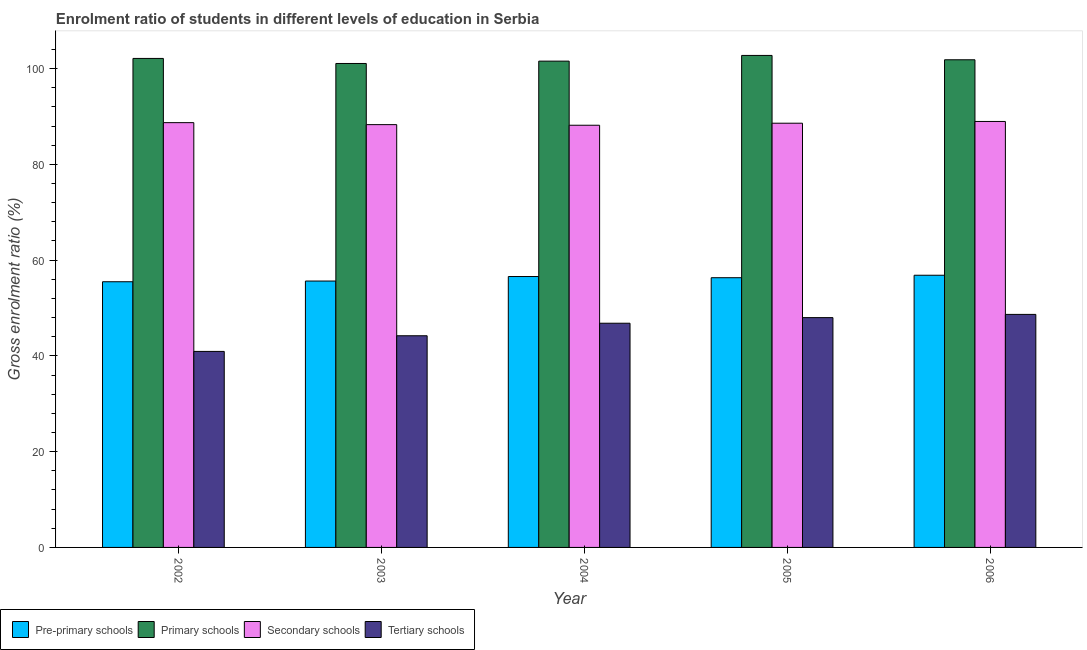Are the number of bars per tick equal to the number of legend labels?
Your answer should be very brief. Yes. How many bars are there on the 4th tick from the left?
Provide a succinct answer. 4. How many bars are there on the 5th tick from the right?
Your response must be concise. 4. What is the label of the 5th group of bars from the left?
Provide a short and direct response. 2006. In how many cases, is the number of bars for a given year not equal to the number of legend labels?
Provide a succinct answer. 0. What is the gross enrolment ratio in primary schools in 2006?
Ensure brevity in your answer.  101.84. Across all years, what is the maximum gross enrolment ratio in secondary schools?
Offer a terse response. 88.96. Across all years, what is the minimum gross enrolment ratio in tertiary schools?
Keep it short and to the point. 40.93. What is the total gross enrolment ratio in secondary schools in the graph?
Offer a very short reply. 442.72. What is the difference between the gross enrolment ratio in primary schools in 2003 and that in 2004?
Ensure brevity in your answer.  -0.49. What is the difference between the gross enrolment ratio in tertiary schools in 2004 and the gross enrolment ratio in secondary schools in 2002?
Offer a terse response. 5.89. What is the average gross enrolment ratio in tertiary schools per year?
Keep it short and to the point. 45.72. In the year 2006, what is the difference between the gross enrolment ratio in pre-primary schools and gross enrolment ratio in secondary schools?
Offer a very short reply. 0. In how many years, is the gross enrolment ratio in primary schools greater than 84 %?
Provide a succinct answer. 5. What is the ratio of the gross enrolment ratio in secondary schools in 2004 to that in 2005?
Give a very brief answer. 1. Is the gross enrolment ratio in secondary schools in 2004 less than that in 2005?
Your answer should be very brief. Yes. Is the difference between the gross enrolment ratio in tertiary schools in 2003 and 2004 greater than the difference between the gross enrolment ratio in secondary schools in 2003 and 2004?
Give a very brief answer. No. What is the difference between the highest and the second highest gross enrolment ratio in secondary schools?
Your response must be concise. 0.25. What is the difference between the highest and the lowest gross enrolment ratio in tertiary schools?
Your answer should be very brief. 7.73. In how many years, is the gross enrolment ratio in secondary schools greater than the average gross enrolment ratio in secondary schools taken over all years?
Make the answer very short. 3. What does the 1st bar from the left in 2005 represents?
Ensure brevity in your answer.  Pre-primary schools. What does the 1st bar from the right in 2002 represents?
Offer a very short reply. Tertiary schools. How many bars are there?
Your response must be concise. 20. Are all the bars in the graph horizontal?
Offer a terse response. No. How many years are there in the graph?
Make the answer very short. 5. What is the difference between two consecutive major ticks on the Y-axis?
Your answer should be compact. 20. Are the values on the major ticks of Y-axis written in scientific E-notation?
Ensure brevity in your answer.  No. Does the graph contain any zero values?
Provide a succinct answer. No. Where does the legend appear in the graph?
Your answer should be very brief. Bottom left. What is the title of the graph?
Provide a short and direct response. Enrolment ratio of students in different levels of education in Serbia. What is the label or title of the X-axis?
Ensure brevity in your answer.  Year. What is the Gross enrolment ratio (%) of Pre-primary schools in 2002?
Keep it short and to the point. 55.48. What is the Gross enrolment ratio (%) of Primary schools in 2002?
Offer a very short reply. 102.12. What is the Gross enrolment ratio (%) in Secondary schools in 2002?
Give a very brief answer. 88.71. What is the Gross enrolment ratio (%) in Tertiary schools in 2002?
Make the answer very short. 40.93. What is the Gross enrolment ratio (%) in Pre-primary schools in 2003?
Your answer should be very brief. 55.63. What is the Gross enrolment ratio (%) in Primary schools in 2003?
Offer a terse response. 101.07. What is the Gross enrolment ratio (%) in Secondary schools in 2003?
Ensure brevity in your answer.  88.29. What is the Gross enrolment ratio (%) of Tertiary schools in 2003?
Give a very brief answer. 44.21. What is the Gross enrolment ratio (%) in Pre-primary schools in 2004?
Provide a short and direct response. 56.57. What is the Gross enrolment ratio (%) in Primary schools in 2004?
Your answer should be very brief. 101.55. What is the Gross enrolment ratio (%) of Secondary schools in 2004?
Offer a terse response. 88.17. What is the Gross enrolment ratio (%) in Tertiary schools in 2004?
Offer a terse response. 46.82. What is the Gross enrolment ratio (%) in Pre-primary schools in 2005?
Your answer should be very brief. 56.33. What is the Gross enrolment ratio (%) of Primary schools in 2005?
Give a very brief answer. 102.75. What is the Gross enrolment ratio (%) in Secondary schools in 2005?
Keep it short and to the point. 88.59. What is the Gross enrolment ratio (%) in Tertiary schools in 2005?
Make the answer very short. 47.99. What is the Gross enrolment ratio (%) in Pre-primary schools in 2006?
Provide a short and direct response. 56.84. What is the Gross enrolment ratio (%) in Primary schools in 2006?
Provide a short and direct response. 101.84. What is the Gross enrolment ratio (%) of Secondary schools in 2006?
Your answer should be compact. 88.96. What is the Gross enrolment ratio (%) of Tertiary schools in 2006?
Ensure brevity in your answer.  48.67. Across all years, what is the maximum Gross enrolment ratio (%) in Pre-primary schools?
Keep it short and to the point. 56.84. Across all years, what is the maximum Gross enrolment ratio (%) of Primary schools?
Your response must be concise. 102.75. Across all years, what is the maximum Gross enrolment ratio (%) of Secondary schools?
Your response must be concise. 88.96. Across all years, what is the maximum Gross enrolment ratio (%) in Tertiary schools?
Give a very brief answer. 48.67. Across all years, what is the minimum Gross enrolment ratio (%) of Pre-primary schools?
Keep it short and to the point. 55.48. Across all years, what is the minimum Gross enrolment ratio (%) in Primary schools?
Provide a short and direct response. 101.07. Across all years, what is the minimum Gross enrolment ratio (%) of Secondary schools?
Make the answer very short. 88.17. Across all years, what is the minimum Gross enrolment ratio (%) of Tertiary schools?
Provide a succinct answer. 40.93. What is the total Gross enrolment ratio (%) in Pre-primary schools in the graph?
Your answer should be compact. 280.86. What is the total Gross enrolment ratio (%) in Primary schools in the graph?
Keep it short and to the point. 509.33. What is the total Gross enrolment ratio (%) of Secondary schools in the graph?
Give a very brief answer. 442.72. What is the total Gross enrolment ratio (%) in Tertiary schools in the graph?
Your response must be concise. 228.62. What is the difference between the Gross enrolment ratio (%) in Pre-primary schools in 2002 and that in 2003?
Ensure brevity in your answer.  -0.15. What is the difference between the Gross enrolment ratio (%) of Primary schools in 2002 and that in 2003?
Provide a short and direct response. 1.05. What is the difference between the Gross enrolment ratio (%) in Secondary schools in 2002 and that in 2003?
Your response must be concise. 0.42. What is the difference between the Gross enrolment ratio (%) of Tertiary schools in 2002 and that in 2003?
Offer a very short reply. -3.27. What is the difference between the Gross enrolment ratio (%) in Pre-primary schools in 2002 and that in 2004?
Make the answer very short. -1.09. What is the difference between the Gross enrolment ratio (%) in Primary schools in 2002 and that in 2004?
Offer a very short reply. 0.56. What is the difference between the Gross enrolment ratio (%) of Secondary schools in 2002 and that in 2004?
Make the answer very short. 0.54. What is the difference between the Gross enrolment ratio (%) of Tertiary schools in 2002 and that in 2004?
Ensure brevity in your answer.  -5.89. What is the difference between the Gross enrolment ratio (%) of Pre-primary schools in 2002 and that in 2005?
Offer a very short reply. -0.84. What is the difference between the Gross enrolment ratio (%) in Primary schools in 2002 and that in 2005?
Provide a succinct answer. -0.63. What is the difference between the Gross enrolment ratio (%) of Secondary schools in 2002 and that in 2005?
Ensure brevity in your answer.  0.12. What is the difference between the Gross enrolment ratio (%) of Tertiary schools in 2002 and that in 2005?
Provide a short and direct response. -7.06. What is the difference between the Gross enrolment ratio (%) in Pre-primary schools in 2002 and that in 2006?
Your answer should be compact. -1.36. What is the difference between the Gross enrolment ratio (%) of Primary schools in 2002 and that in 2006?
Your answer should be very brief. 0.28. What is the difference between the Gross enrolment ratio (%) of Secondary schools in 2002 and that in 2006?
Your answer should be very brief. -0.25. What is the difference between the Gross enrolment ratio (%) of Tertiary schools in 2002 and that in 2006?
Your answer should be compact. -7.73. What is the difference between the Gross enrolment ratio (%) in Pre-primary schools in 2003 and that in 2004?
Your response must be concise. -0.94. What is the difference between the Gross enrolment ratio (%) of Primary schools in 2003 and that in 2004?
Keep it short and to the point. -0.49. What is the difference between the Gross enrolment ratio (%) of Secondary schools in 2003 and that in 2004?
Provide a succinct answer. 0.13. What is the difference between the Gross enrolment ratio (%) of Tertiary schools in 2003 and that in 2004?
Offer a very short reply. -2.61. What is the difference between the Gross enrolment ratio (%) in Pre-primary schools in 2003 and that in 2005?
Your answer should be very brief. -0.7. What is the difference between the Gross enrolment ratio (%) in Primary schools in 2003 and that in 2005?
Give a very brief answer. -1.68. What is the difference between the Gross enrolment ratio (%) in Secondary schools in 2003 and that in 2005?
Offer a very short reply. -0.3. What is the difference between the Gross enrolment ratio (%) in Tertiary schools in 2003 and that in 2005?
Make the answer very short. -3.79. What is the difference between the Gross enrolment ratio (%) in Pre-primary schools in 2003 and that in 2006?
Give a very brief answer. -1.21. What is the difference between the Gross enrolment ratio (%) in Primary schools in 2003 and that in 2006?
Your response must be concise. -0.77. What is the difference between the Gross enrolment ratio (%) in Secondary schools in 2003 and that in 2006?
Your answer should be compact. -0.66. What is the difference between the Gross enrolment ratio (%) of Tertiary schools in 2003 and that in 2006?
Give a very brief answer. -4.46. What is the difference between the Gross enrolment ratio (%) in Pre-primary schools in 2004 and that in 2005?
Offer a terse response. 0.25. What is the difference between the Gross enrolment ratio (%) in Primary schools in 2004 and that in 2005?
Ensure brevity in your answer.  -1.19. What is the difference between the Gross enrolment ratio (%) in Secondary schools in 2004 and that in 2005?
Provide a succinct answer. -0.42. What is the difference between the Gross enrolment ratio (%) of Tertiary schools in 2004 and that in 2005?
Offer a very short reply. -1.17. What is the difference between the Gross enrolment ratio (%) in Pre-primary schools in 2004 and that in 2006?
Keep it short and to the point. -0.27. What is the difference between the Gross enrolment ratio (%) in Primary schools in 2004 and that in 2006?
Provide a short and direct response. -0.28. What is the difference between the Gross enrolment ratio (%) of Secondary schools in 2004 and that in 2006?
Your response must be concise. -0.79. What is the difference between the Gross enrolment ratio (%) of Tertiary schools in 2004 and that in 2006?
Your answer should be compact. -1.85. What is the difference between the Gross enrolment ratio (%) of Pre-primary schools in 2005 and that in 2006?
Make the answer very short. -0.51. What is the difference between the Gross enrolment ratio (%) in Primary schools in 2005 and that in 2006?
Offer a terse response. 0.91. What is the difference between the Gross enrolment ratio (%) of Secondary schools in 2005 and that in 2006?
Make the answer very short. -0.37. What is the difference between the Gross enrolment ratio (%) of Tertiary schools in 2005 and that in 2006?
Offer a very short reply. -0.67. What is the difference between the Gross enrolment ratio (%) of Pre-primary schools in 2002 and the Gross enrolment ratio (%) of Primary schools in 2003?
Keep it short and to the point. -45.58. What is the difference between the Gross enrolment ratio (%) in Pre-primary schools in 2002 and the Gross enrolment ratio (%) in Secondary schools in 2003?
Keep it short and to the point. -32.81. What is the difference between the Gross enrolment ratio (%) of Pre-primary schools in 2002 and the Gross enrolment ratio (%) of Tertiary schools in 2003?
Provide a short and direct response. 11.28. What is the difference between the Gross enrolment ratio (%) of Primary schools in 2002 and the Gross enrolment ratio (%) of Secondary schools in 2003?
Offer a very short reply. 13.83. What is the difference between the Gross enrolment ratio (%) of Primary schools in 2002 and the Gross enrolment ratio (%) of Tertiary schools in 2003?
Provide a succinct answer. 57.91. What is the difference between the Gross enrolment ratio (%) of Secondary schools in 2002 and the Gross enrolment ratio (%) of Tertiary schools in 2003?
Offer a very short reply. 44.5. What is the difference between the Gross enrolment ratio (%) of Pre-primary schools in 2002 and the Gross enrolment ratio (%) of Primary schools in 2004?
Offer a very short reply. -46.07. What is the difference between the Gross enrolment ratio (%) in Pre-primary schools in 2002 and the Gross enrolment ratio (%) in Secondary schools in 2004?
Offer a terse response. -32.68. What is the difference between the Gross enrolment ratio (%) in Pre-primary schools in 2002 and the Gross enrolment ratio (%) in Tertiary schools in 2004?
Provide a short and direct response. 8.66. What is the difference between the Gross enrolment ratio (%) in Primary schools in 2002 and the Gross enrolment ratio (%) in Secondary schools in 2004?
Your answer should be compact. 13.95. What is the difference between the Gross enrolment ratio (%) of Primary schools in 2002 and the Gross enrolment ratio (%) of Tertiary schools in 2004?
Make the answer very short. 55.3. What is the difference between the Gross enrolment ratio (%) of Secondary schools in 2002 and the Gross enrolment ratio (%) of Tertiary schools in 2004?
Keep it short and to the point. 41.89. What is the difference between the Gross enrolment ratio (%) of Pre-primary schools in 2002 and the Gross enrolment ratio (%) of Primary schools in 2005?
Ensure brevity in your answer.  -47.26. What is the difference between the Gross enrolment ratio (%) of Pre-primary schools in 2002 and the Gross enrolment ratio (%) of Secondary schools in 2005?
Your answer should be very brief. -33.11. What is the difference between the Gross enrolment ratio (%) in Pre-primary schools in 2002 and the Gross enrolment ratio (%) in Tertiary schools in 2005?
Your answer should be compact. 7.49. What is the difference between the Gross enrolment ratio (%) of Primary schools in 2002 and the Gross enrolment ratio (%) of Secondary schools in 2005?
Provide a short and direct response. 13.53. What is the difference between the Gross enrolment ratio (%) of Primary schools in 2002 and the Gross enrolment ratio (%) of Tertiary schools in 2005?
Ensure brevity in your answer.  54.13. What is the difference between the Gross enrolment ratio (%) in Secondary schools in 2002 and the Gross enrolment ratio (%) in Tertiary schools in 2005?
Offer a very short reply. 40.72. What is the difference between the Gross enrolment ratio (%) in Pre-primary schools in 2002 and the Gross enrolment ratio (%) in Primary schools in 2006?
Offer a terse response. -46.36. What is the difference between the Gross enrolment ratio (%) in Pre-primary schools in 2002 and the Gross enrolment ratio (%) in Secondary schools in 2006?
Offer a very short reply. -33.47. What is the difference between the Gross enrolment ratio (%) of Pre-primary schools in 2002 and the Gross enrolment ratio (%) of Tertiary schools in 2006?
Make the answer very short. 6.82. What is the difference between the Gross enrolment ratio (%) in Primary schools in 2002 and the Gross enrolment ratio (%) in Secondary schools in 2006?
Give a very brief answer. 13.16. What is the difference between the Gross enrolment ratio (%) in Primary schools in 2002 and the Gross enrolment ratio (%) in Tertiary schools in 2006?
Your response must be concise. 53.45. What is the difference between the Gross enrolment ratio (%) of Secondary schools in 2002 and the Gross enrolment ratio (%) of Tertiary schools in 2006?
Provide a short and direct response. 40.04. What is the difference between the Gross enrolment ratio (%) in Pre-primary schools in 2003 and the Gross enrolment ratio (%) in Primary schools in 2004?
Provide a succinct answer. -45.92. What is the difference between the Gross enrolment ratio (%) in Pre-primary schools in 2003 and the Gross enrolment ratio (%) in Secondary schools in 2004?
Offer a very short reply. -32.54. What is the difference between the Gross enrolment ratio (%) in Pre-primary schools in 2003 and the Gross enrolment ratio (%) in Tertiary schools in 2004?
Offer a very short reply. 8.81. What is the difference between the Gross enrolment ratio (%) of Primary schools in 2003 and the Gross enrolment ratio (%) of Secondary schools in 2004?
Provide a short and direct response. 12.9. What is the difference between the Gross enrolment ratio (%) of Primary schools in 2003 and the Gross enrolment ratio (%) of Tertiary schools in 2004?
Ensure brevity in your answer.  54.25. What is the difference between the Gross enrolment ratio (%) in Secondary schools in 2003 and the Gross enrolment ratio (%) in Tertiary schools in 2004?
Make the answer very short. 41.47. What is the difference between the Gross enrolment ratio (%) in Pre-primary schools in 2003 and the Gross enrolment ratio (%) in Primary schools in 2005?
Your answer should be compact. -47.12. What is the difference between the Gross enrolment ratio (%) in Pre-primary schools in 2003 and the Gross enrolment ratio (%) in Secondary schools in 2005?
Your answer should be very brief. -32.96. What is the difference between the Gross enrolment ratio (%) of Pre-primary schools in 2003 and the Gross enrolment ratio (%) of Tertiary schools in 2005?
Your response must be concise. 7.64. What is the difference between the Gross enrolment ratio (%) of Primary schools in 2003 and the Gross enrolment ratio (%) of Secondary schools in 2005?
Keep it short and to the point. 12.47. What is the difference between the Gross enrolment ratio (%) in Primary schools in 2003 and the Gross enrolment ratio (%) in Tertiary schools in 2005?
Your answer should be very brief. 53.07. What is the difference between the Gross enrolment ratio (%) in Secondary schools in 2003 and the Gross enrolment ratio (%) in Tertiary schools in 2005?
Your answer should be compact. 40.3. What is the difference between the Gross enrolment ratio (%) in Pre-primary schools in 2003 and the Gross enrolment ratio (%) in Primary schools in 2006?
Your response must be concise. -46.21. What is the difference between the Gross enrolment ratio (%) in Pre-primary schools in 2003 and the Gross enrolment ratio (%) in Secondary schools in 2006?
Make the answer very short. -33.32. What is the difference between the Gross enrolment ratio (%) in Pre-primary schools in 2003 and the Gross enrolment ratio (%) in Tertiary schools in 2006?
Provide a succinct answer. 6.97. What is the difference between the Gross enrolment ratio (%) in Primary schools in 2003 and the Gross enrolment ratio (%) in Secondary schools in 2006?
Provide a succinct answer. 12.11. What is the difference between the Gross enrolment ratio (%) in Primary schools in 2003 and the Gross enrolment ratio (%) in Tertiary schools in 2006?
Keep it short and to the point. 52.4. What is the difference between the Gross enrolment ratio (%) in Secondary schools in 2003 and the Gross enrolment ratio (%) in Tertiary schools in 2006?
Your answer should be compact. 39.63. What is the difference between the Gross enrolment ratio (%) of Pre-primary schools in 2004 and the Gross enrolment ratio (%) of Primary schools in 2005?
Offer a terse response. -46.17. What is the difference between the Gross enrolment ratio (%) in Pre-primary schools in 2004 and the Gross enrolment ratio (%) in Secondary schools in 2005?
Your answer should be very brief. -32.02. What is the difference between the Gross enrolment ratio (%) of Pre-primary schools in 2004 and the Gross enrolment ratio (%) of Tertiary schools in 2005?
Provide a short and direct response. 8.58. What is the difference between the Gross enrolment ratio (%) in Primary schools in 2004 and the Gross enrolment ratio (%) in Secondary schools in 2005?
Keep it short and to the point. 12.96. What is the difference between the Gross enrolment ratio (%) of Primary schools in 2004 and the Gross enrolment ratio (%) of Tertiary schools in 2005?
Keep it short and to the point. 53.56. What is the difference between the Gross enrolment ratio (%) of Secondary schools in 2004 and the Gross enrolment ratio (%) of Tertiary schools in 2005?
Your answer should be very brief. 40.18. What is the difference between the Gross enrolment ratio (%) in Pre-primary schools in 2004 and the Gross enrolment ratio (%) in Primary schools in 2006?
Provide a short and direct response. -45.27. What is the difference between the Gross enrolment ratio (%) of Pre-primary schools in 2004 and the Gross enrolment ratio (%) of Secondary schools in 2006?
Ensure brevity in your answer.  -32.38. What is the difference between the Gross enrolment ratio (%) of Pre-primary schools in 2004 and the Gross enrolment ratio (%) of Tertiary schools in 2006?
Keep it short and to the point. 7.91. What is the difference between the Gross enrolment ratio (%) of Primary schools in 2004 and the Gross enrolment ratio (%) of Secondary schools in 2006?
Your answer should be very brief. 12.6. What is the difference between the Gross enrolment ratio (%) of Primary schools in 2004 and the Gross enrolment ratio (%) of Tertiary schools in 2006?
Offer a terse response. 52.89. What is the difference between the Gross enrolment ratio (%) of Secondary schools in 2004 and the Gross enrolment ratio (%) of Tertiary schools in 2006?
Ensure brevity in your answer.  39.5. What is the difference between the Gross enrolment ratio (%) of Pre-primary schools in 2005 and the Gross enrolment ratio (%) of Primary schools in 2006?
Provide a succinct answer. -45.51. What is the difference between the Gross enrolment ratio (%) of Pre-primary schools in 2005 and the Gross enrolment ratio (%) of Secondary schools in 2006?
Make the answer very short. -32.63. What is the difference between the Gross enrolment ratio (%) of Pre-primary schools in 2005 and the Gross enrolment ratio (%) of Tertiary schools in 2006?
Ensure brevity in your answer.  7.66. What is the difference between the Gross enrolment ratio (%) in Primary schools in 2005 and the Gross enrolment ratio (%) in Secondary schools in 2006?
Give a very brief answer. 13.79. What is the difference between the Gross enrolment ratio (%) of Primary schools in 2005 and the Gross enrolment ratio (%) of Tertiary schools in 2006?
Make the answer very short. 54.08. What is the difference between the Gross enrolment ratio (%) of Secondary schools in 2005 and the Gross enrolment ratio (%) of Tertiary schools in 2006?
Your response must be concise. 39.92. What is the average Gross enrolment ratio (%) of Pre-primary schools per year?
Offer a very short reply. 56.17. What is the average Gross enrolment ratio (%) of Primary schools per year?
Ensure brevity in your answer.  101.87. What is the average Gross enrolment ratio (%) of Secondary schools per year?
Your response must be concise. 88.54. What is the average Gross enrolment ratio (%) of Tertiary schools per year?
Provide a succinct answer. 45.72. In the year 2002, what is the difference between the Gross enrolment ratio (%) in Pre-primary schools and Gross enrolment ratio (%) in Primary schools?
Your response must be concise. -46.64. In the year 2002, what is the difference between the Gross enrolment ratio (%) in Pre-primary schools and Gross enrolment ratio (%) in Secondary schools?
Ensure brevity in your answer.  -33.23. In the year 2002, what is the difference between the Gross enrolment ratio (%) in Pre-primary schools and Gross enrolment ratio (%) in Tertiary schools?
Offer a very short reply. 14.55. In the year 2002, what is the difference between the Gross enrolment ratio (%) of Primary schools and Gross enrolment ratio (%) of Secondary schools?
Keep it short and to the point. 13.41. In the year 2002, what is the difference between the Gross enrolment ratio (%) in Primary schools and Gross enrolment ratio (%) in Tertiary schools?
Your response must be concise. 61.19. In the year 2002, what is the difference between the Gross enrolment ratio (%) of Secondary schools and Gross enrolment ratio (%) of Tertiary schools?
Your answer should be very brief. 47.78. In the year 2003, what is the difference between the Gross enrolment ratio (%) of Pre-primary schools and Gross enrolment ratio (%) of Primary schools?
Provide a succinct answer. -45.43. In the year 2003, what is the difference between the Gross enrolment ratio (%) of Pre-primary schools and Gross enrolment ratio (%) of Secondary schools?
Keep it short and to the point. -32.66. In the year 2003, what is the difference between the Gross enrolment ratio (%) of Pre-primary schools and Gross enrolment ratio (%) of Tertiary schools?
Provide a succinct answer. 11.43. In the year 2003, what is the difference between the Gross enrolment ratio (%) in Primary schools and Gross enrolment ratio (%) in Secondary schools?
Provide a short and direct response. 12.77. In the year 2003, what is the difference between the Gross enrolment ratio (%) in Primary schools and Gross enrolment ratio (%) in Tertiary schools?
Make the answer very short. 56.86. In the year 2003, what is the difference between the Gross enrolment ratio (%) of Secondary schools and Gross enrolment ratio (%) of Tertiary schools?
Make the answer very short. 44.09. In the year 2004, what is the difference between the Gross enrolment ratio (%) of Pre-primary schools and Gross enrolment ratio (%) of Primary schools?
Provide a short and direct response. -44.98. In the year 2004, what is the difference between the Gross enrolment ratio (%) in Pre-primary schools and Gross enrolment ratio (%) in Secondary schools?
Provide a succinct answer. -31.59. In the year 2004, what is the difference between the Gross enrolment ratio (%) in Pre-primary schools and Gross enrolment ratio (%) in Tertiary schools?
Your answer should be very brief. 9.75. In the year 2004, what is the difference between the Gross enrolment ratio (%) in Primary schools and Gross enrolment ratio (%) in Secondary schools?
Provide a short and direct response. 13.39. In the year 2004, what is the difference between the Gross enrolment ratio (%) of Primary schools and Gross enrolment ratio (%) of Tertiary schools?
Offer a very short reply. 54.74. In the year 2004, what is the difference between the Gross enrolment ratio (%) in Secondary schools and Gross enrolment ratio (%) in Tertiary schools?
Ensure brevity in your answer.  41.35. In the year 2005, what is the difference between the Gross enrolment ratio (%) of Pre-primary schools and Gross enrolment ratio (%) of Primary schools?
Give a very brief answer. -46.42. In the year 2005, what is the difference between the Gross enrolment ratio (%) in Pre-primary schools and Gross enrolment ratio (%) in Secondary schools?
Ensure brevity in your answer.  -32.26. In the year 2005, what is the difference between the Gross enrolment ratio (%) of Pre-primary schools and Gross enrolment ratio (%) of Tertiary schools?
Offer a terse response. 8.33. In the year 2005, what is the difference between the Gross enrolment ratio (%) of Primary schools and Gross enrolment ratio (%) of Secondary schools?
Provide a short and direct response. 14.16. In the year 2005, what is the difference between the Gross enrolment ratio (%) in Primary schools and Gross enrolment ratio (%) in Tertiary schools?
Ensure brevity in your answer.  54.75. In the year 2005, what is the difference between the Gross enrolment ratio (%) in Secondary schools and Gross enrolment ratio (%) in Tertiary schools?
Provide a succinct answer. 40.6. In the year 2006, what is the difference between the Gross enrolment ratio (%) of Pre-primary schools and Gross enrolment ratio (%) of Primary schools?
Make the answer very short. -45. In the year 2006, what is the difference between the Gross enrolment ratio (%) of Pre-primary schools and Gross enrolment ratio (%) of Secondary schools?
Offer a very short reply. -32.12. In the year 2006, what is the difference between the Gross enrolment ratio (%) of Pre-primary schools and Gross enrolment ratio (%) of Tertiary schools?
Keep it short and to the point. 8.18. In the year 2006, what is the difference between the Gross enrolment ratio (%) of Primary schools and Gross enrolment ratio (%) of Secondary schools?
Your response must be concise. 12.88. In the year 2006, what is the difference between the Gross enrolment ratio (%) of Primary schools and Gross enrolment ratio (%) of Tertiary schools?
Your answer should be very brief. 53.17. In the year 2006, what is the difference between the Gross enrolment ratio (%) in Secondary schools and Gross enrolment ratio (%) in Tertiary schools?
Provide a short and direct response. 40.29. What is the ratio of the Gross enrolment ratio (%) of Pre-primary schools in 2002 to that in 2003?
Keep it short and to the point. 1. What is the ratio of the Gross enrolment ratio (%) of Primary schools in 2002 to that in 2003?
Offer a terse response. 1.01. What is the ratio of the Gross enrolment ratio (%) in Tertiary schools in 2002 to that in 2003?
Make the answer very short. 0.93. What is the ratio of the Gross enrolment ratio (%) in Pre-primary schools in 2002 to that in 2004?
Your answer should be compact. 0.98. What is the ratio of the Gross enrolment ratio (%) in Primary schools in 2002 to that in 2004?
Provide a succinct answer. 1.01. What is the ratio of the Gross enrolment ratio (%) of Secondary schools in 2002 to that in 2004?
Provide a succinct answer. 1.01. What is the ratio of the Gross enrolment ratio (%) of Tertiary schools in 2002 to that in 2004?
Your answer should be compact. 0.87. What is the ratio of the Gross enrolment ratio (%) in Pre-primary schools in 2002 to that in 2005?
Ensure brevity in your answer.  0.98. What is the ratio of the Gross enrolment ratio (%) in Tertiary schools in 2002 to that in 2005?
Your answer should be compact. 0.85. What is the ratio of the Gross enrolment ratio (%) of Pre-primary schools in 2002 to that in 2006?
Provide a short and direct response. 0.98. What is the ratio of the Gross enrolment ratio (%) of Primary schools in 2002 to that in 2006?
Your answer should be compact. 1. What is the ratio of the Gross enrolment ratio (%) in Tertiary schools in 2002 to that in 2006?
Your response must be concise. 0.84. What is the ratio of the Gross enrolment ratio (%) in Pre-primary schools in 2003 to that in 2004?
Make the answer very short. 0.98. What is the ratio of the Gross enrolment ratio (%) in Primary schools in 2003 to that in 2004?
Offer a very short reply. 1. What is the ratio of the Gross enrolment ratio (%) of Tertiary schools in 2003 to that in 2004?
Your answer should be compact. 0.94. What is the ratio of the Gross enrolment ratio (%) of Primary schools in 2003 to that in 2005?
Provide a succinct answer. 0.98. What is the ratio of the Gross enrolment ratio (%) in Tertiary schools in 2003 to that in 2005?
Provide a short and direct response. 0.92. What is the ratio of the Gross enrolment ratio (%) of Pre-primary schools in 2003 to that in 2006?
Make the answer very short. 0.98. What is the ratio of the Gross enrolment ratio (%) of Primary schools in 2003 to that in 2006?
Your answer should be compact. 0.99. What is the ratio of the Gross enrolment ratio (%) in Secondary schools in 2003 to that in 2006?
Provide a succinct answer. 0.99. What is the ratio of the Gross enrolment ratio (%) in Tertiary schools in 2003 to that in 2006?
Offer a terse response. 0.91. What is the ratio of the Gross enrolment ratio (%) in Pre-primary schools in 2004 to that in 2005?
Your answer should be compact. 1. What is the ratio of the Gross enrolment ratio (%) in Primary schools in 2004 to that in 2005?
Offer a very short reply. 0.99. What is the ratio of the Gross enrolment ratio (%) of Tertiary schools in 2004 to that in 2005?
Provide a succinct answer. 0.98. What is the ratio of the Gross enrolment ratio (%) of Pre-primary schools in 2004 to that in 2006?
Keep it short and to the point. 1. What is the ratio of the Gross enrolment ratio (%) in Primary schools in 2004 to that in 2006?
Provide a short and direct response. 1. What is the ratio of the Gross enrolment ratio (%) in Secondary schools in 2004 to that in 2006?
Your answer should be very brief. 0.99. What is the ratio of the Gross enrolment ratio (%) of Tertiary schools in 2004 to that in 2006?
Your answer should be compact. 0.96. What is the ratio of the Gross enrolment ratio (%) in Primary schools in 2005 to that in 2006?
Provide a short and direct response. 1.01. What is the ratio of the Gross enrolment ratio (%) of Tertiary schools in 2005 to that in 2006?
Offer a very short reply. 0.99. What is the difference between the highest and the second highest Gross enrolment ratio (%) of Pre-primary schools?
Give a very brief answer. 0.27. What is the difference between the highest and the second highest Gross enrolment ratio (%) in Primary schools?
Offer a very short reply. 0.63. What is the difference between the highest and the second highest Gross enrolment ratio (%) in Secondary schools?
Your answer should be very brief. 0.25. What is the difference between the highest and the second highest Gross enrolment ratio (%) in Tertiary schools?
Provide a succinct answer. 0.67. What is the difference between the highest and the lowest Gross enrolment ratio (%) in Pre-primary schools?
Your response must be concise. 1.36. What is the difference between the highest and the lowest Gross enrolment ratio (%) in Primary schools?
Give a very brief answer. 1.68. What is the difference between the highest and the lowest Gross enrolment ratio (%) in Secondary schools?
Make the answer very short. 0.79. What is the difference between the highest and the lowest Gross enrolment ratio (%) in Tertiary schools?
Keep it short and to the point. 7.73. 